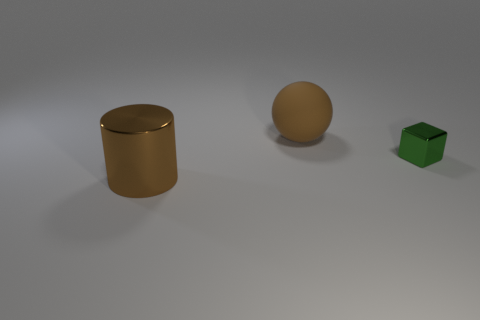Is there any other thing that is the same material as the large sphere?
Give a very brief answer. No. Does the big cylinder have the same material as the green block?
Offer a terse response. Yes. There is a tiny metal thing that is behind the thing that is in front of the tiny metallic block; what number of brown rubber things are on the left side of it?
Offer a very short reply. 1. How many big gray rubber cylinders are there?
Provide a short and direct response. 0. Are there fewer metallic blocks that are behind the small block than large rubber objects in front of the big cylinder?
Offer a terse response. No. Is the number of balls left of the big brown sphere less than the number of tiny red matte cylinders?
Ensure brevity in your answer.  No. The big object in front of the shiny object behind the brown thing that is to the left of the rubber thing is made of what material?
Keep it short and to the point. Metal. What number of objects are brown things that are right of the large metal object or objects in front of the brown matte object?
Ensure brevity in your answer.  3. What number of metal things are large brown objects or small green cubes?
Give a very brief answer. 2. What is the shape of the large thing that is made of the same material as the tiny green thing?
Your answer should be very brief. Cylinder. 